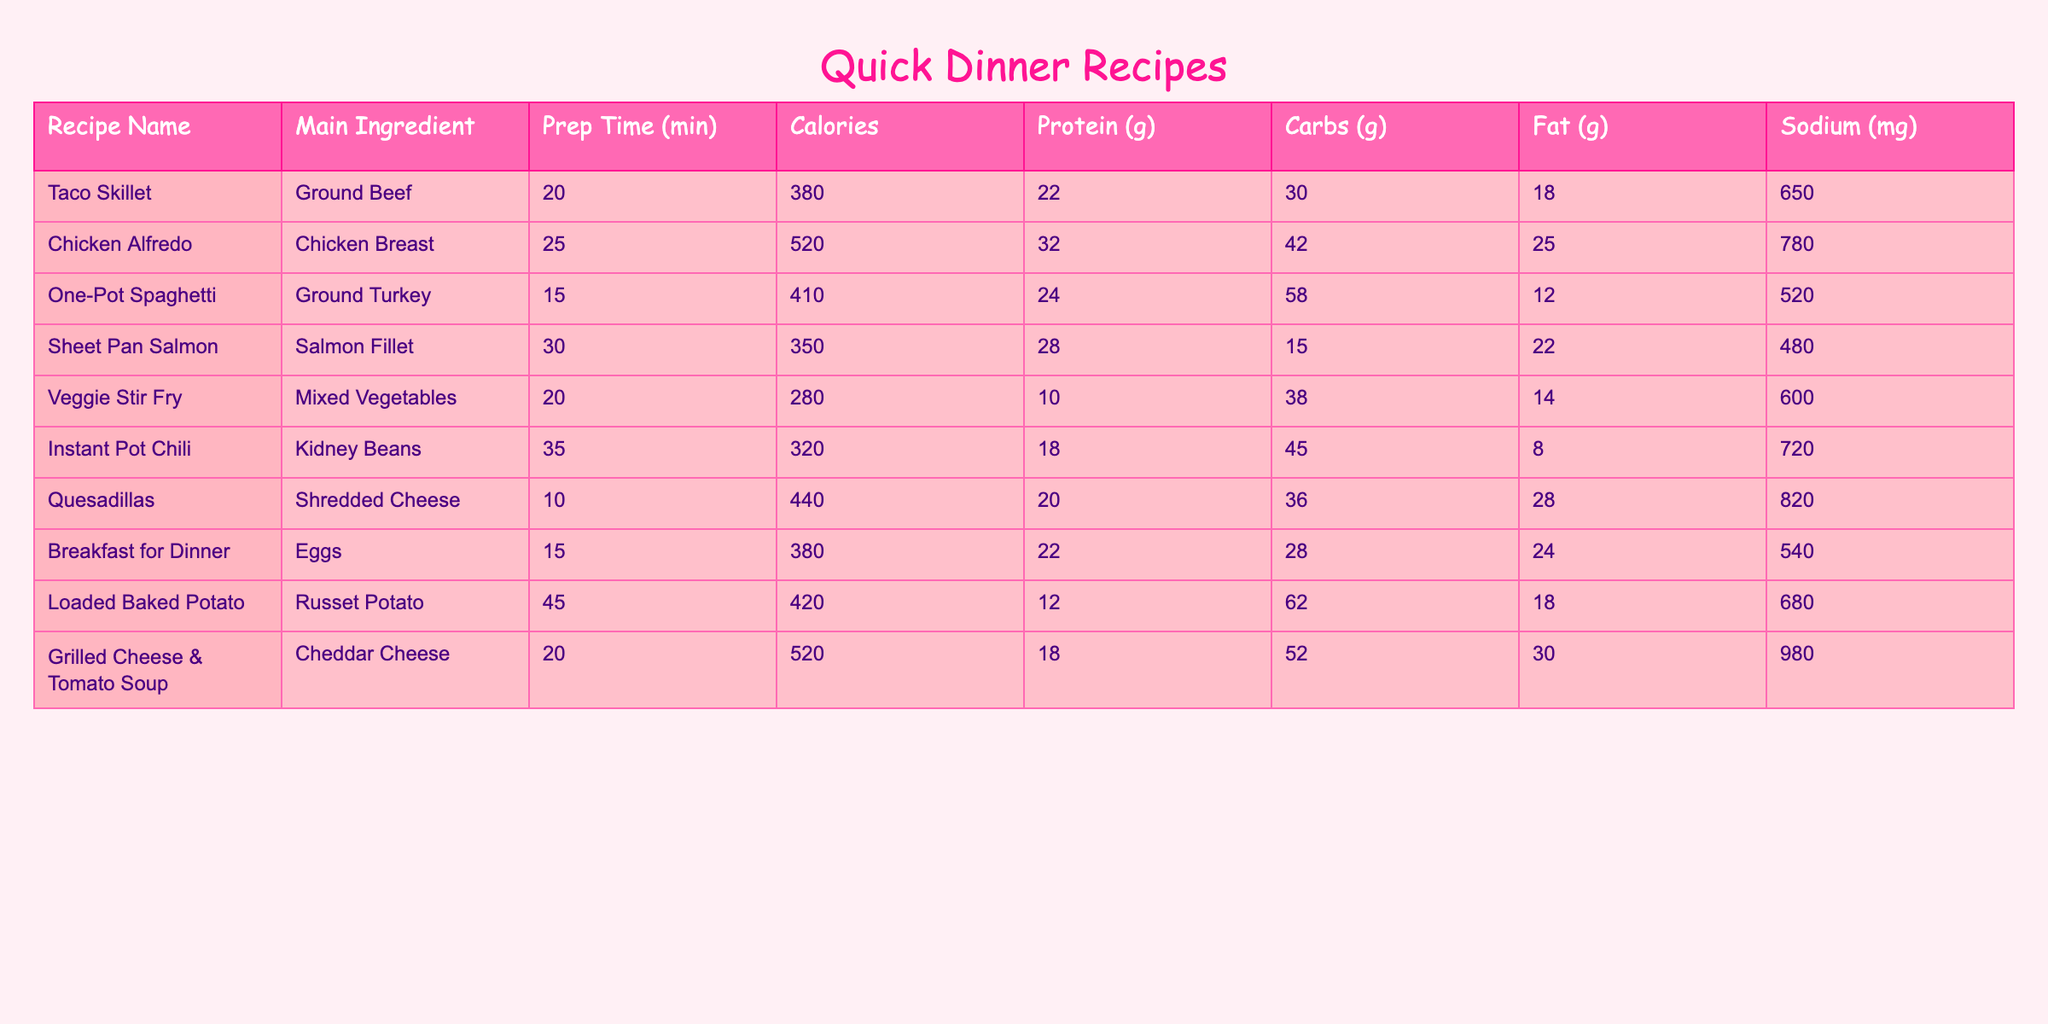What is the main ingredient in the Chicken Alfredo recipe? The table lists the main ingredients for each recipe, and under Chicken Alfredo, it shows "Chicken Breast".
Answer: Chicken Breast Which recipe has the highest calorie count? By examining the Calories column, I see that Chicken Alfredo has 520 calories, which is more than any other recipe listed.
Answer: Chicken Alfredo What is the prep time for the Taco Skillet? Looking at the Prep Time column, Taco Skillet is listed with a prep time of 20 minutes.
Answer: 20 minutes How much protein is in the One-Pot Spaghetti? The table directly shows the protein content for each recipe, and One-Pot Spaghetti has 24 grams of protein.
Answer: 24 grams What is the total amount of carbs in the Veggie Stir Fry and Loaded Baked Potato combined? Adding the carbs from each recipe: Veggie Stir Fry has 38 grams, and Loaded Baked Potato has 62 grams. So, 38 + 62 = 100 grams.
Answer: 100 grams Is the sodium content in Grilled Cheese & Tomato Soup greater than that in Instant Pot Chili? Grilled Cheese & Tomato Soup has 980 mg of sodium, while Instant Pot Chili has 720 mg. Since 980 is greater than 720, the statement is true.
Answer: Yes What is the average prep time for these recipes? Adding all the prep times: 20 + 25 + 15 + 30 + 20 + 35 + 10 + 15 + 45 + 20 = 235 minutes. There are 10 recipes, so average prep time is 235 / 10 = 23.5 minutes.
Answer: 23.5 minutes How many recipes have a protein content of 20 grams or more? Reviewing the Protein column, the recipes with 20 grams or more are Taco Skillet, Chicken Alfredo, Quesadillas, Breakfast for Dinner, and Grilled Cheese & Tomato Soup, totaling 5 recipes.
Answer: 5 recipes What is the difference in calories between the Sheet Pan Salmon and the Quesadillas? The calorie count for Sheet Pan Salmon is 350 calories, and for Quesadillas, it's 440 calories. The difference is 440 - 350 = 90 calories.
Answer: 90 calories Which recipe has the least amount of fat? Checking the Fat column, Sheet Pan Salmon has 22 grams of fat, which is the least compared to the other recipes.
Answer: Sheet Pan Salmon 